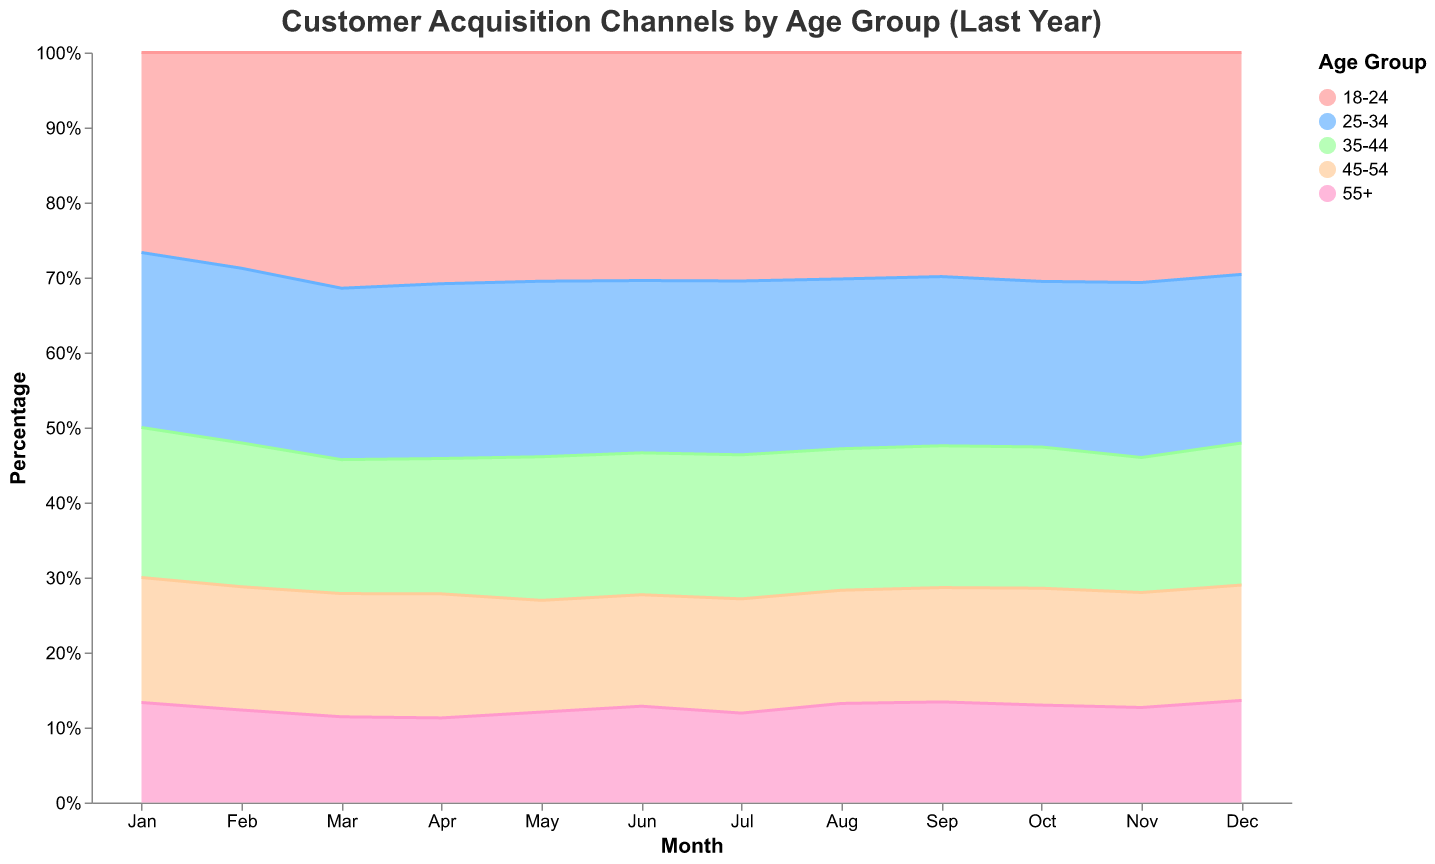What is the title of the chart? The title can be found at the top of the chart.
Answer: Customer Acquisition Channels by Age Group (Last Year) Which age group has the largest share through Social Media in December? Look for the month of December, and identify which age group occupies the largest area corresponding to Social Media at the top.
Answer: 18-24 In which month does the 18-24 age group have the highest percentage of customer acquisition through Social Media? Track the area for the 18-24 age group (usually at the top in bright color) and find the month where this area is highest.
Answer: September How does the share of SEO change over the months for the 55+ age group? Locate the SEO area in the chart and follow its changes for the 55+ age group across the months (area at the bottom, usually pink).
Answer: It generally increases from January to April, reduces slightly in May, rises again and peaks in June, and fluctuates from July to December Compare the percentage share of Email acquisitions for the 25-34 and 35-44 age groups in March. Look for March and compare the area given to Email acquisition for the two age groups.
Answer: 35-44 has a slight larger share than 25-34 Which age group sees the most consistent share of customer acquisitions through Direct channels over the year? Track the area corresponding to Direct channels for each age group over all months, and identify which age group has the most nearly uniform area throughout the chart.
Answer: 55+ In which month does the 45-54 age group have the highest combined share for Social Media and Direct channels? Add the areas for Social Media and Direct channels for the 45-54 age group month by month, and identify the month with the highest combined area.
Answer: July How does the overall share of Paid Search compare across different age groups in November? Observe the relative heights of the sections corresponding to Paid Search for each age group in November.
Answer: Relatively balanced across all age groups, slightly higher for 55+ 